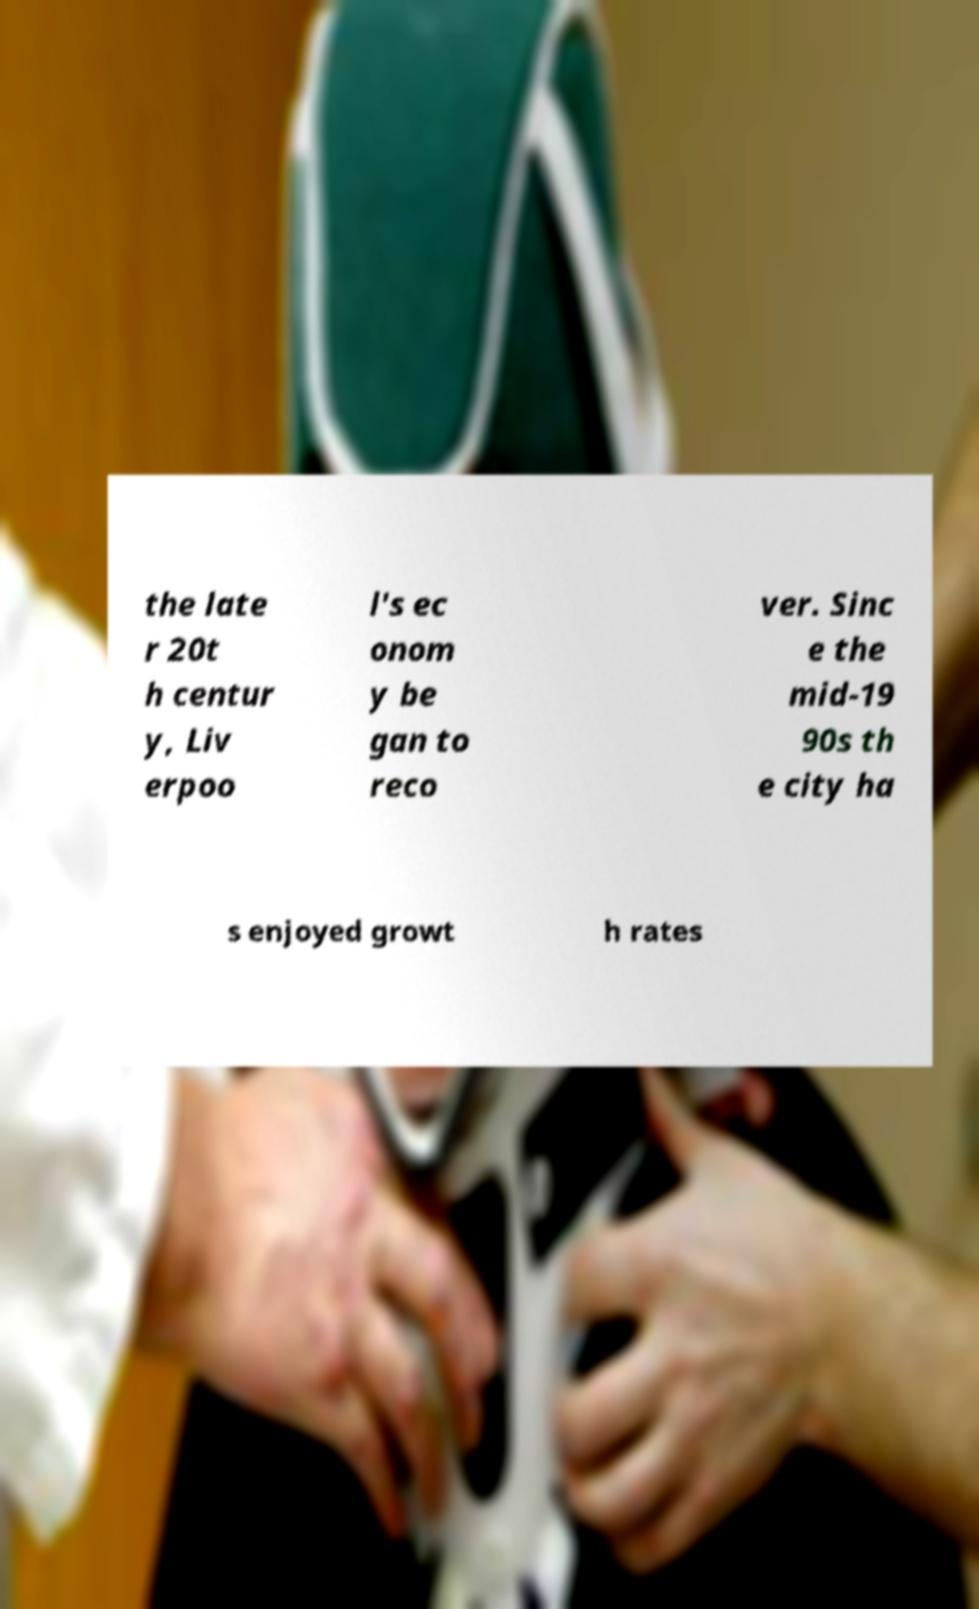There's text embedded in this image that I need extracted. Can you transcribe it verbatim? the late r 20t h centur y, Liv erpoo l's ec onom y be gan to reco ver. Sinc e the mid-19 90s th e city ha s enjoyed growt h rates 